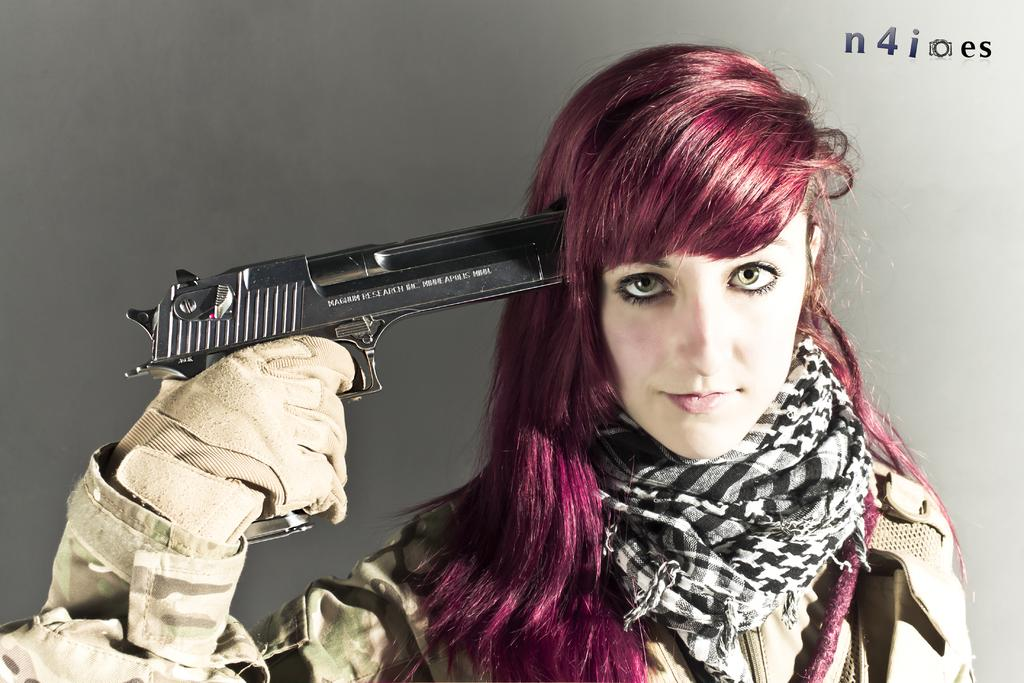Who is the main subject in the image? There is a woman in the image. What type of clothing is the woman wearing? The woman is wearing a military dress. Are there any accessories visible in the image? Yes, the woman is wearing a scarf around her neck and gloves. What is the woman holding in the image? The woman is holding a gun towards her head. What type of secretary can be seen working on the road in the image? There is no secretary or road present in the image; it features a woman in a military dress holding a gun towards her head. How many feet are visible in the image? The image does not show any feet; it only shows the woman from the waist up. 